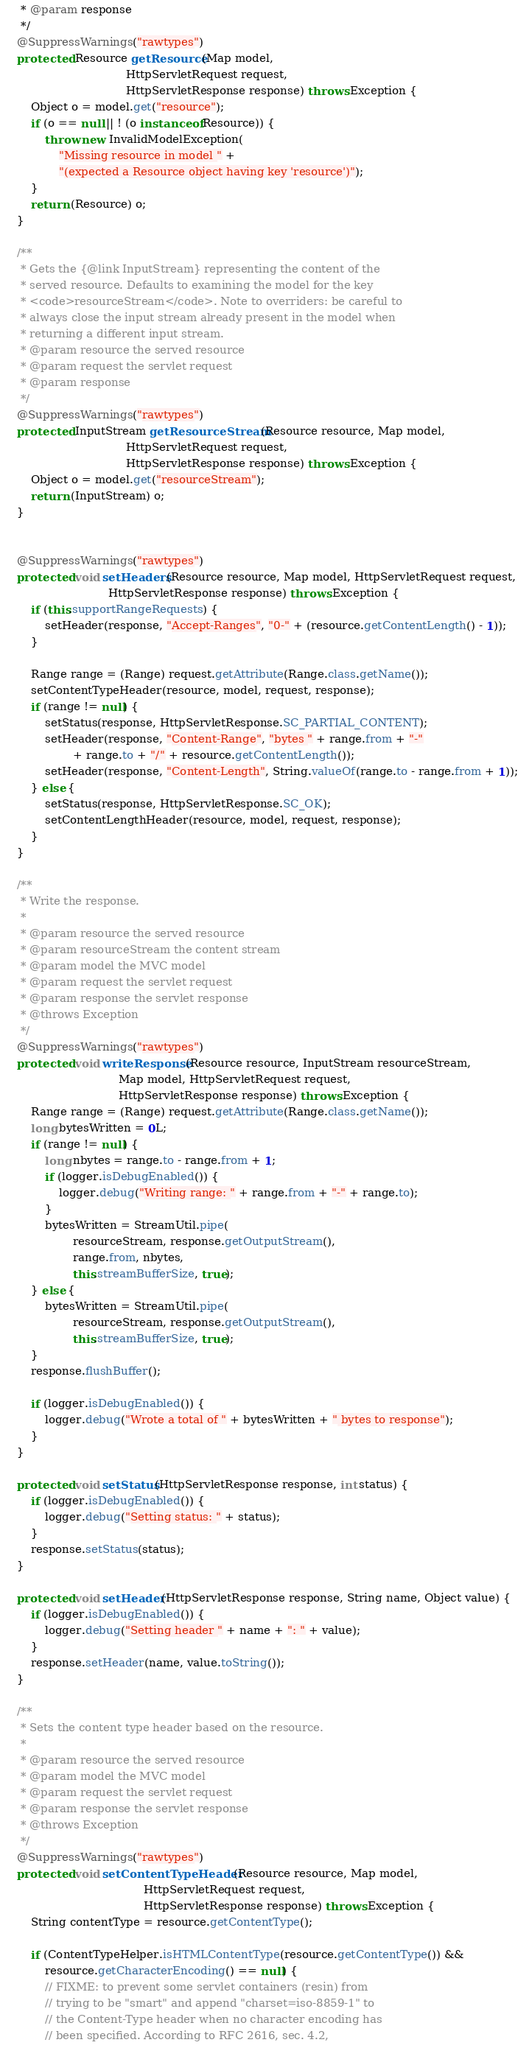<code> <loc_0><loc_0><loc_500><loc_500><_Java_>     * @param response
     */
    @SuppressWarnings("rawtypes")
    protected Resource getResource(Map model,
                                   HttpServletRequest request,
                                   HttpServletResponse response) throws Exception {
        Object o = model.get("resource");
        if (o == null || ! (o instanceof Resource)) {
            throw new InvalidModelException(
                "Missing resource in model " +
                "(expected a Resource object having key 'resource')");
        }
        return (Resource) o;
    }
    
    /**
     * Gets the {@link InputStream} representing the content of the
     * served resource. Defaults to examining the model for the key
     * <code>resourceStream</code>. Note to overriders: be careful to
     * always close the input stream already present in the model when
     * returning a different input stream.
     * @param resource the served resource
     * @param request the servlet request
     * @param response
     */
    @SuppressWarnings("rawtypes")
    protected InputStream getResourceStream(Resource resource, Map model,
                                   HttpServletRequest request,
                                   HttpServletResponse response) throws Exception {
        Object o = model.get("resourceStream");
        return (InputStream) o;
    }
    

    @SuppressWarnings("rawtypes")
    protected void setHeaders(Resource resource, Map model, HttpServletRequest request,
                              HttpServletResponse response) throws Exception {
        if (this.supportRangeRequests) {
            setHeader(response, "Accept-Ranges", "0-" + (resource.getContentLength() - 1));
        }
        
        Range range = (Range) request.getAttribute(Range.class.getName());
        setContentTypeHeader(resource, model, request, response);
        if (range != null) {
            setStatus(response, HttpServletResponse.SC_PARTIAL_CONTENT);
            setHeader(response, "Content-Range", "bytes " + range.from + "-" 
                    + range.to + "/" + resource.getContentLength());
            setHeader(response, "Content-Length", String.valueOf(range.to - range.from + 1));
        } else {
            setStatus(response, HttpServletResponse.SC_OK);
            setContentLengthHeader(resource, model, request, response);
        }
    }

    /**
     * Write the response.
     * 
     * @param resource the served resource
     * @param resourceStream the content stream
     * @param model the MVC model
     * @param request the servlet request
     * @param response the servlet response
     * @throws Exception
     */
    @SuppressWarnings("rawtypes")
    protected void writeResponse(Resource resource, InputStream resourceStream,
                                 Map model, HttpServletRequest request,
                                 HttpServletResponse response) throws Exception {
        Range range = (Range) request.getAttribute(Range.class.getName());
        long bytesWritten = 0L;
        if (range != null) {
            long nbytes = range.to - range.from + 1;
            if (logger.isDebugEnabled()) {
                logger.debug("Writing range: " + range.from + "-" + range.to);
            }
            bytesWritten = StreamUtil.pipe(
                    resourceStream, response.getOutputStream(), 
                    range.from, nbytes,
                    this.streamBufferSize, true);
        } else {
            bytesWritten = StreamUtil.pipe(
                    resourceStream, response.getOutputStream(), 
                    this.streamBufferSize, true);
        }
        response.flushBuffer();
        
        if (logger.isDebugEnabled()) {
            logger.debug("Wrote a total of " + bytesWritten + " bytes to response");
        }
    }
    
    protected void setStatus(HttpServletResponse response, int status) {
        if (logger.isDebugEnabled()) {
            logger.debug("Setting status: " + status);
        }
        response.setStatus(status);
    }

    protected void setHeader(HttpServletResponse response, String name, Object value) {
        if (logger.isDebugEnabled()) {
            logger.debug("Setting header " + name + ": " + value);
        }
        response.setHeader(name, value.toString());
    }
    
    /**
     * Sets the content type header based on the resource.
     * 
     * @param resource the served resource
     * @param model the MVC model
     * @param request the servlet request
     * @param response the servlet response
     * @throws Exception
     */
    @SuppressWarnings("rawtypes")
    protected void setContentTypeHeader(Resource resource, Map model,
                                        HttpServletRequest request,
                                        HttpServletResponse response) throws Exception {
        String contentType = resource.getContentType();
        
        if (ContentTypeHelper.isHTMLContentType(resource.getContentType()) &&
            resource.getCharacterEncoding() == null) {
            // FIXME: to prevent some servlet containers (resin) from
            // trying to be "smart" and append "charset=iso-8859-1" to
            // the Content-Type header when no character encoding has
            // been specified. According to RFC 2616, sec. 4.2,</code> 